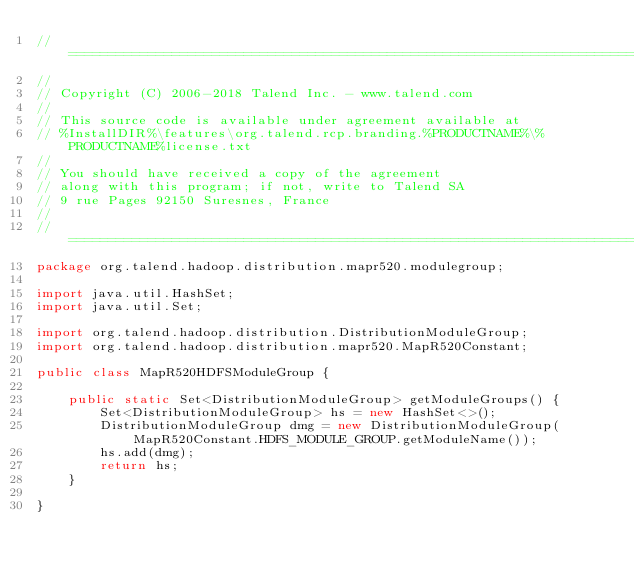<code> <loc_0><loc_0><loc_500><loc_500><_Java_>// ============================================================================
//
// Copyright (C) 2006-2018 Talend Inc. - www.talend.com
//
// This source code is available under agreement available at
// %InstallDIR%\features\org.talend.rcp.branding.%PRODUCTNAME%\%PRODUCTNAME%license.txt
//
// You should have received a copy of the agreement
// along with this program; if not, write to Talend SA
// 9 rue Pages 92150 Suresnes, France
//
// ============================================================================
package org.talend.hadoop.distribution.mapr520.modulegroup;

import java.util.HashSet;
import java.util.Set;

import org.talend.hadoop.distribution.DistributionModuleGroup;
import org.talend.hadoop.distribution.mapr520.MapR520Constant;

public class MapR520HDFSModuleGroup {

    public static Set<DistributionModuleGroup> getModuleGroups() {
        Set<DistributionModuleGroup> hs = new HashSet<>();
        DistributionModuleGroup dmg = new DistributionModuleGroup(MapR520Constant.HDFS_MODULE_GROUP.getModuleName());
        hs.add(dmg);
        return hs;
    }

}
</code> 